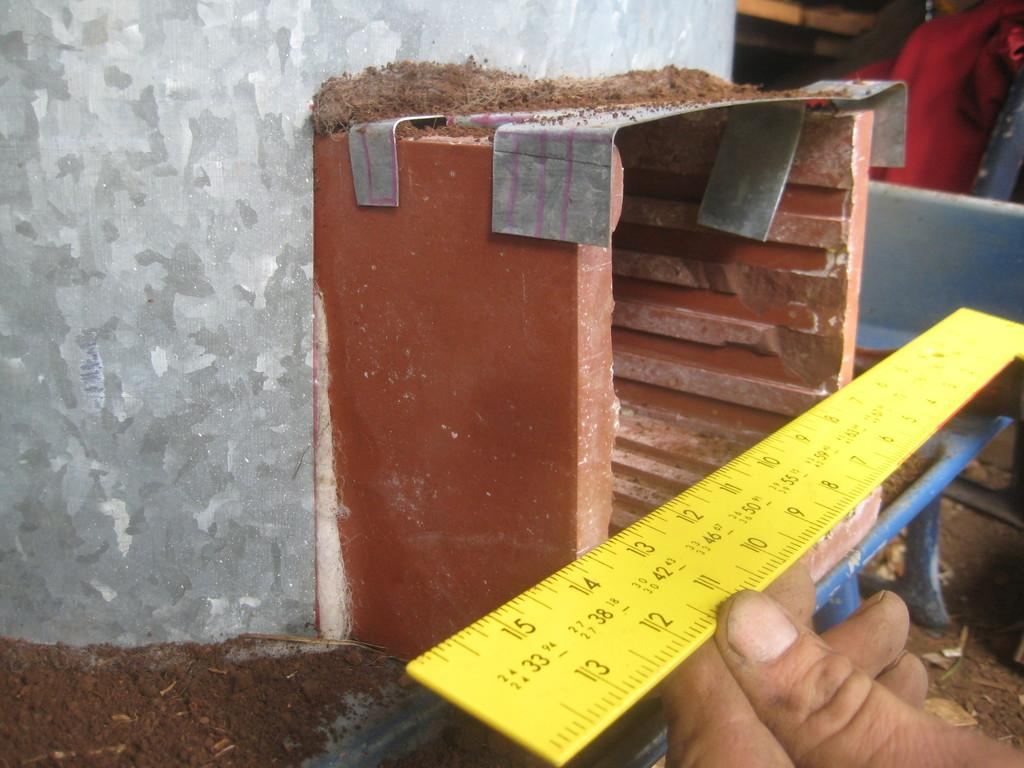Provide a one-sentence caption for the provided image. A 14 inch ruler is showing both inches and centimeters. 